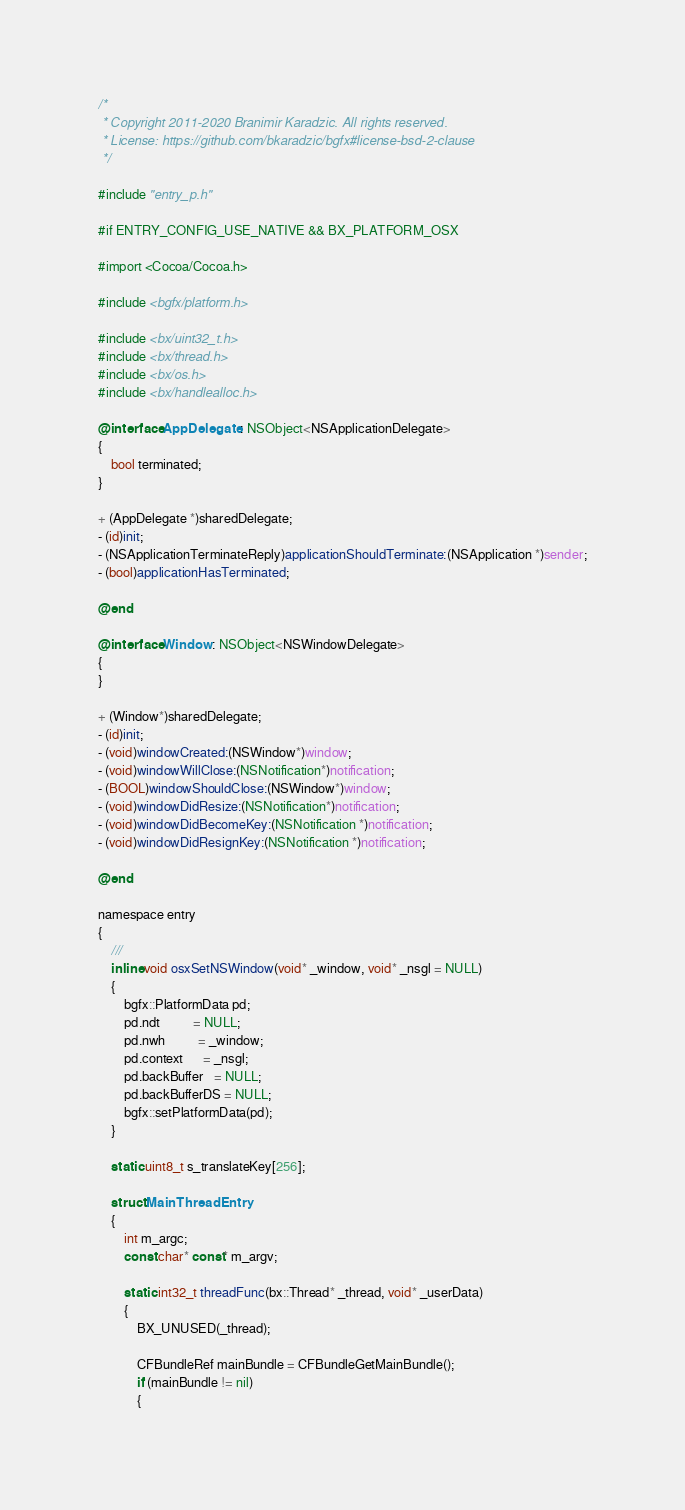<code> <loc_0><loc_0><loc_500><loc_500><_ObjectiveC_>/*
 * Copyright 2011-2020 Branimir Karadzic. All rights reserved.
 * License: https://github.com/bkaradzic/bgfx#license-bsd-2-clause
 */

#include "entry_p.h"

#if ENTRY_CONFIG_USE_NATIVE && BX_PLATFORM_OSX

#import <Cocoa/Cocoa.h>

#include <bgfx/platform.h>

#include <bx/uint32_t.h>
#include <bx/thread.h>
#include <bx/os.h>
#include <bx/handlealloc.h>

@interface AppDelegate : NSObject<NSApplicationDelegate>
{
	bool terminated;
}

+ (AppDelegate *)sharedDelegate;
- (id)init;
- (NSApplicationTerminateReply)applicationShouldTerminate:(NSApplication *)sender;
- (bool)applicationHasTerminated;

@end

@interface Window : NSObject<NSWindowDelegate>
{
}

+ (Window*)sharedDelegate;
- (id)init;
- (void)windowCreated:(NSWindow*)window;
- (void)windowWillClose:(NSNotification*)notification;
- (BOOL)windowShouldClose:(NSWindow*)window;
- (void)windowDidResize:(NSNotification*)notification;
- (void)windowDidBecomeKey:(NSNotification *)notification;
- (void)windowDidResignKey:(NSNotification *)notification;

@end

namespace entry
{
	///
	inline void osxSetNSWindow(void* _window, void* _nsgl = NULL)
	{
		bgfx::PlatformData pd;
		pd.ndt          = NULL;
		pd.nwh          = _window;
		pd.context      = _nsgl;
		pd.backBuffer   = NULL;
		pd.backBufferDS = NULL;
		bgfx::setPlatformData(pd);
	}

	static uint8_t s_translateKey[256];

	struct MainThreadEntry
	{
		int m_argc;
		const char* const* m_argv;

		static int32_t threadFunc(bx::Thread* _thread, void* _userData)
		{
			BX_UNUSED(_thread);

			CFBundleRef mainBundle = CFBundleGetMainBundle();
			if (mainBundle != nil)
			{</code> 